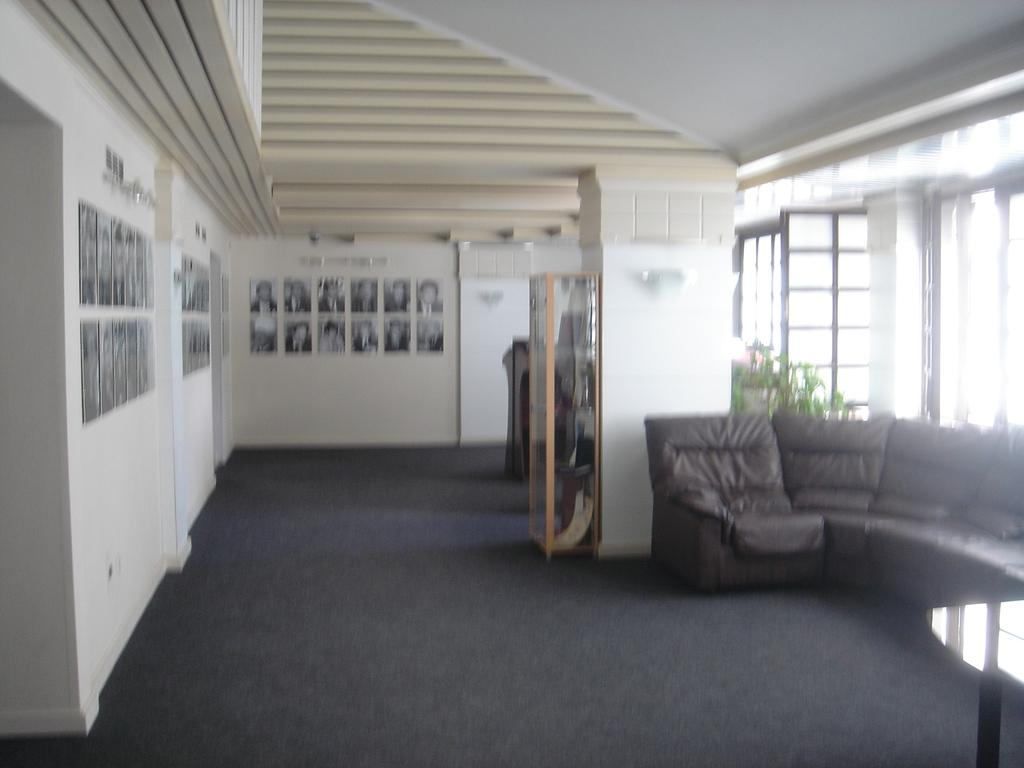What is attached to the wall in the image? There are photo frames attached to the wall. What type of seating is visible in the image? There is an unoccupied sofa in the image. What piece of furniture can be seen in the image besides the sofa? There is a table in the image. What type of doors are on the right side of the image? There are glass doors on the right side of the image. What group of letters can be seen floating in the mist in the image? There is no mist or group of letters present in the image. 